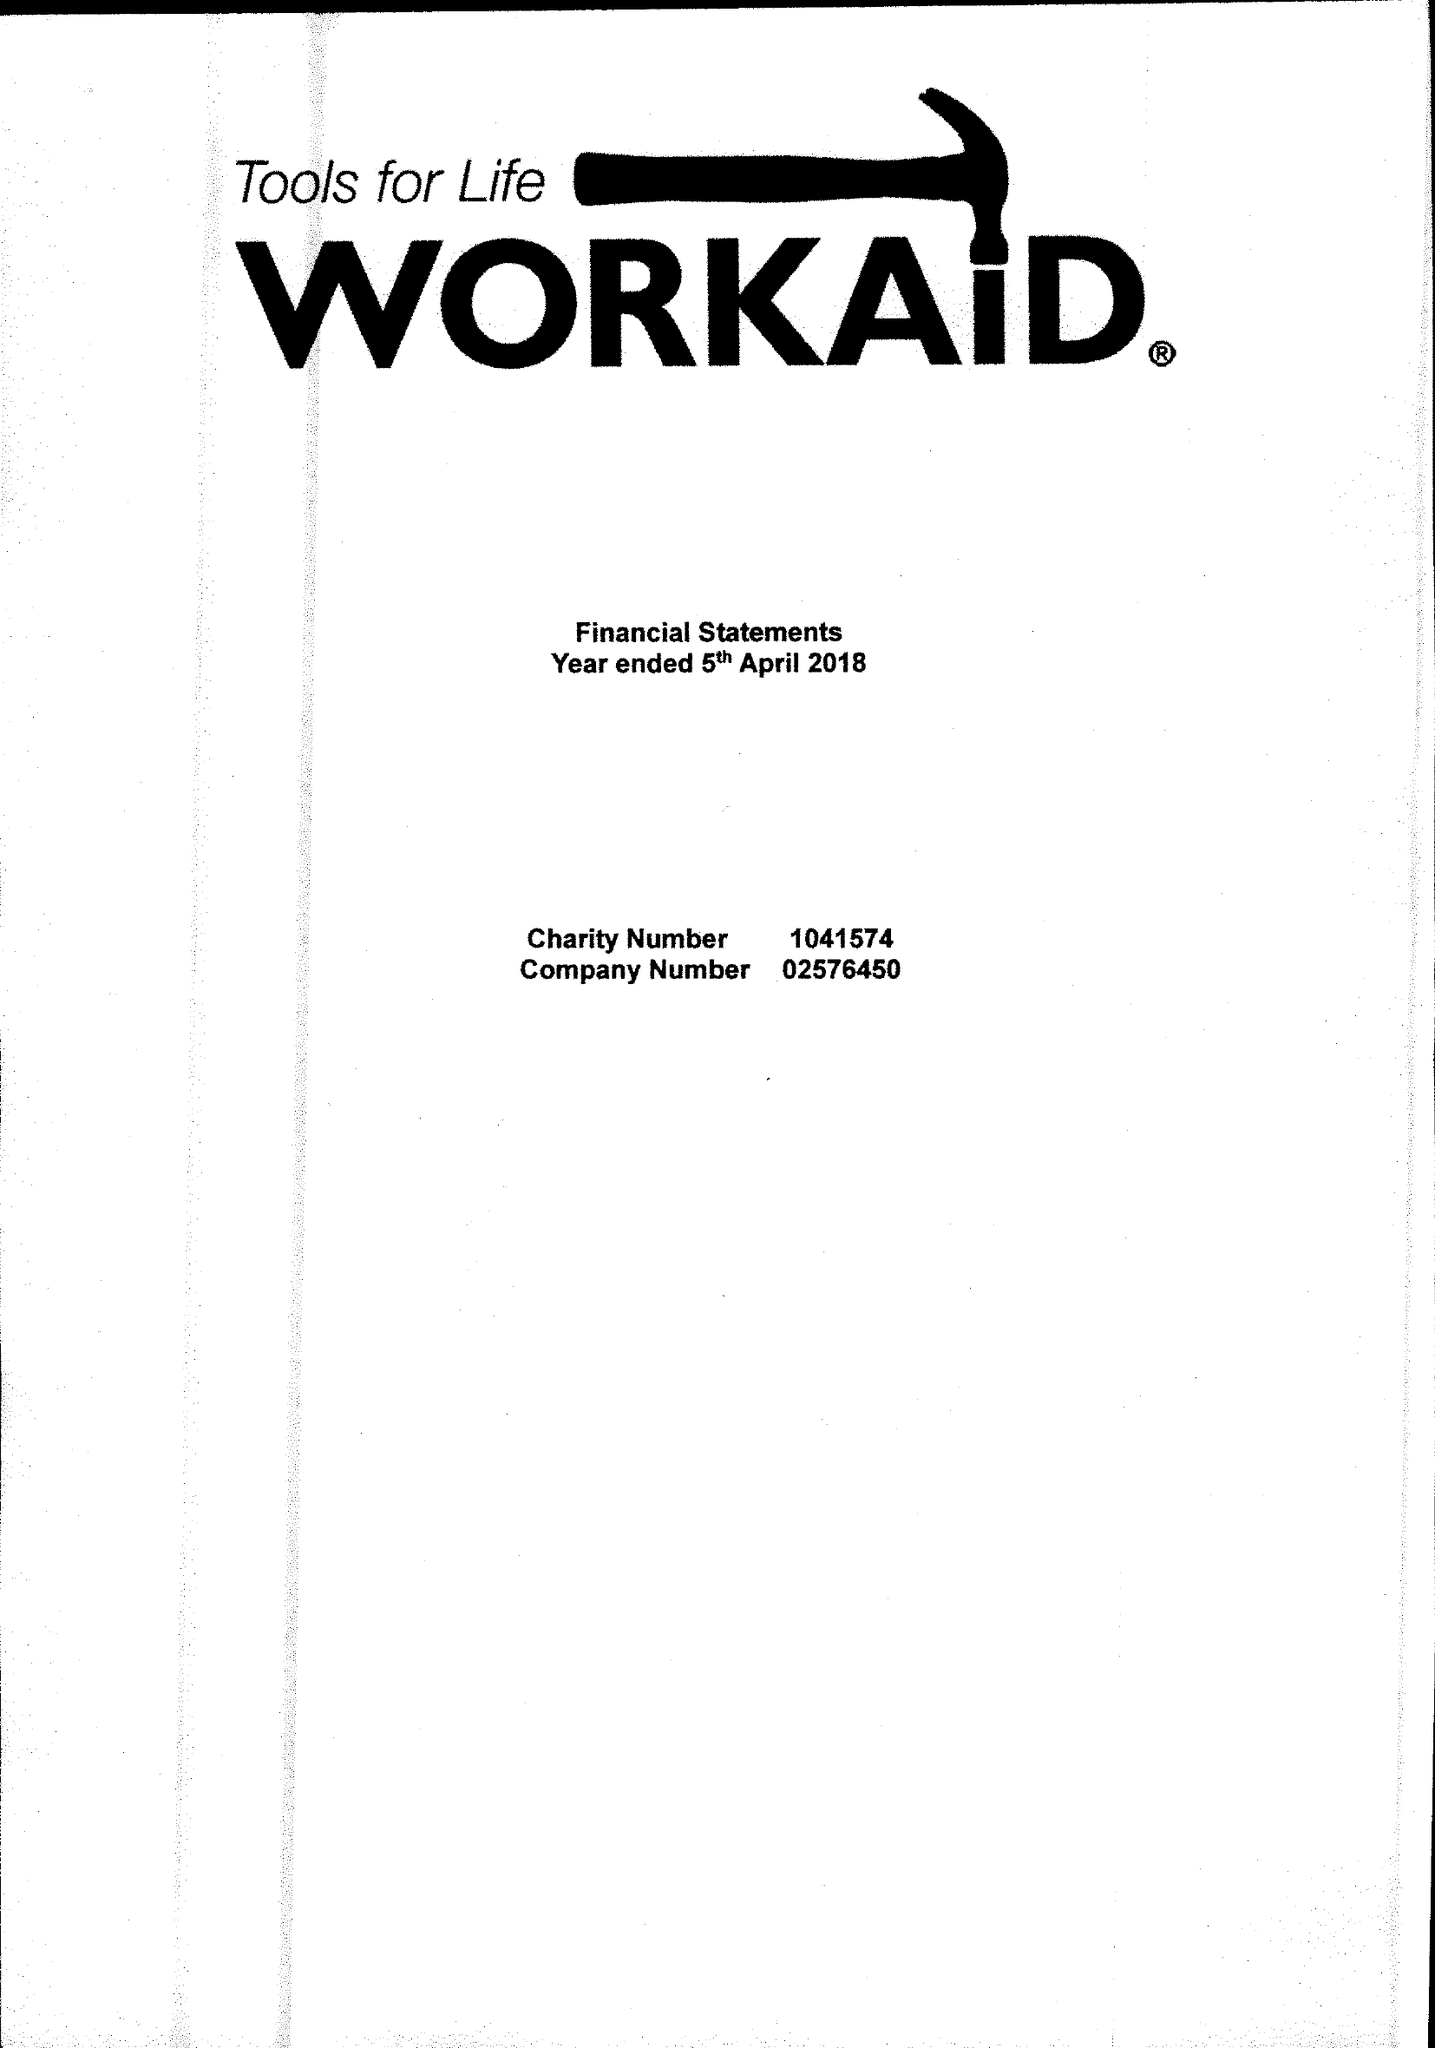What is the value for the income_annually_in_british_pounds?
Answer the question using a single word or phrase. 318328.00 